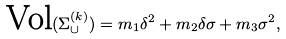Convert formula to latex. <formula><loc_0><loc_0><loc_500><loc_500>\text {Vol} ( \Sigma _ { \cup } ^ { ( k ) } ) = m _ { 1 } \delta ^ { 2 } + m _ { 2 } \delta \sigma + m _ { 3 } \sigma ^ { 2 } ,</formula> 